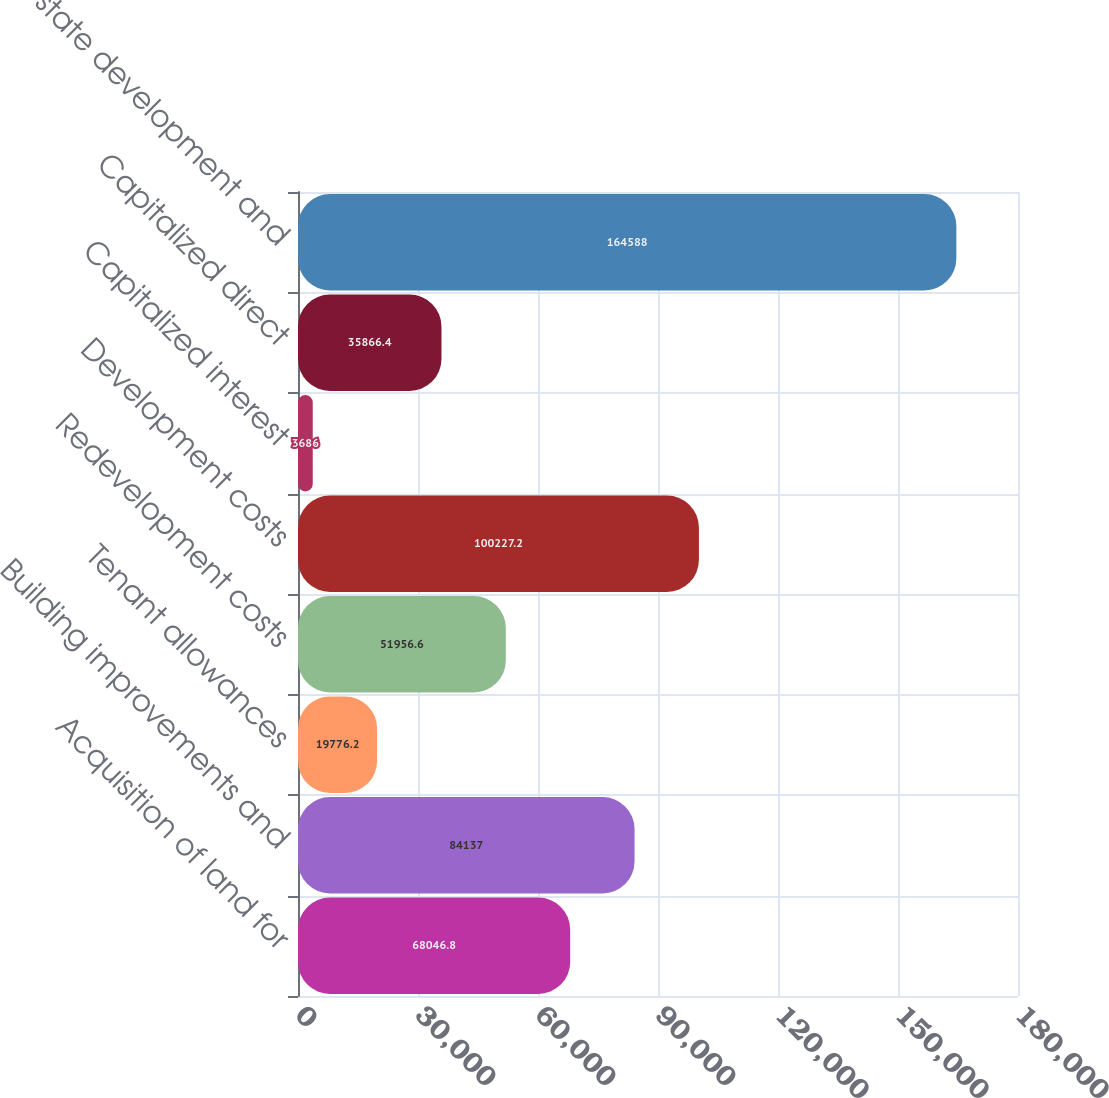<chart> <loc_0><loc_0><loc_500><loc_500><bar_chart><fcel>Acquisition of land for<fcel>Building improvements and<fcel>Tenant allowances<fcel>Redevelopment costs<fcel>Development costs<fcel>Capitalized interest<fcel>Capitalized direct<fcel>Real estate development and<nl><fcel>68046.8<fcel>84137<fcel>19776.2<fcel>51956.6<fcel>100227<fcel>3686<fcel>35866.4<fcel>164588<nl></chart> 